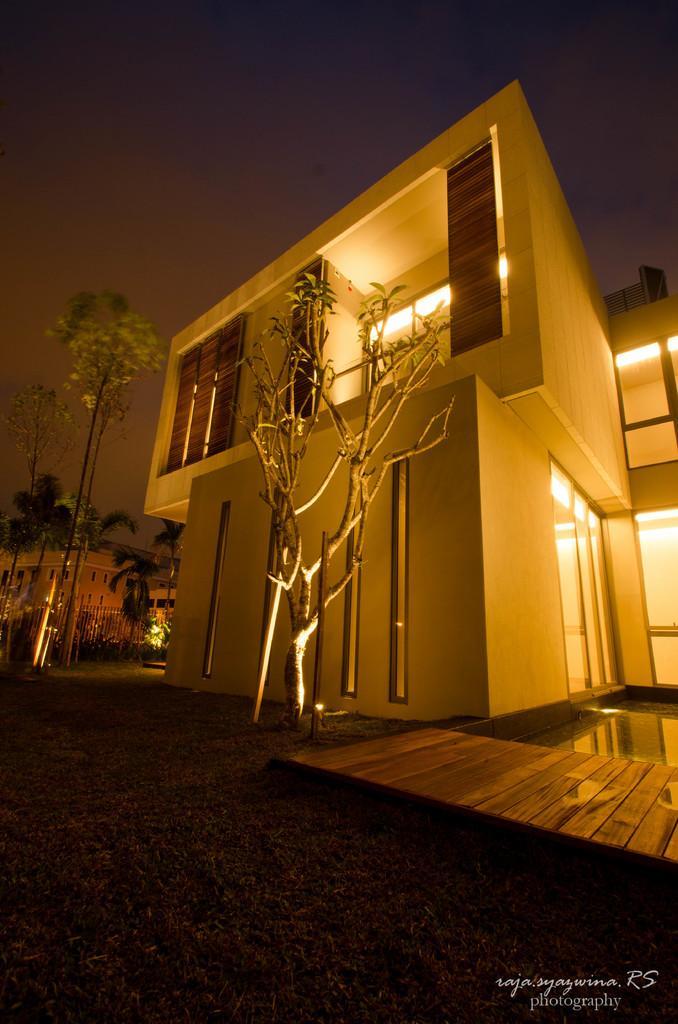In one or two sentences, can you explain what this image depicts? In this image I can see the ground, few trees, few buildings, few lights, the water and few poles. In the background I can see the dark sky. 